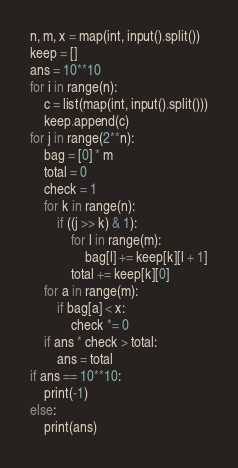<code> <loc_0><loc_0><loc_500><loc_500><_Python_>n, m, x = map(int, input().split())
keep = []
ans = 10**10
for i in range(n):
    c = list(map(int, input().split()))
    keep.append(c)
for j in range(2**n):
    bag = [0] * m
    total = 0
    check = 1
    for k in range(n):
        if ((j >> k) & 1):
            for l in range(m):
                bag[l] += keep[k][l + 1]
            total += keep[k][0]
    for a in range(m):
        if bag[a] < x:
            check *= 0
    if ans * check > total:
        ans = total
if ans == 10**10:
    print(-1)
else:
    print(ans)
</code> 